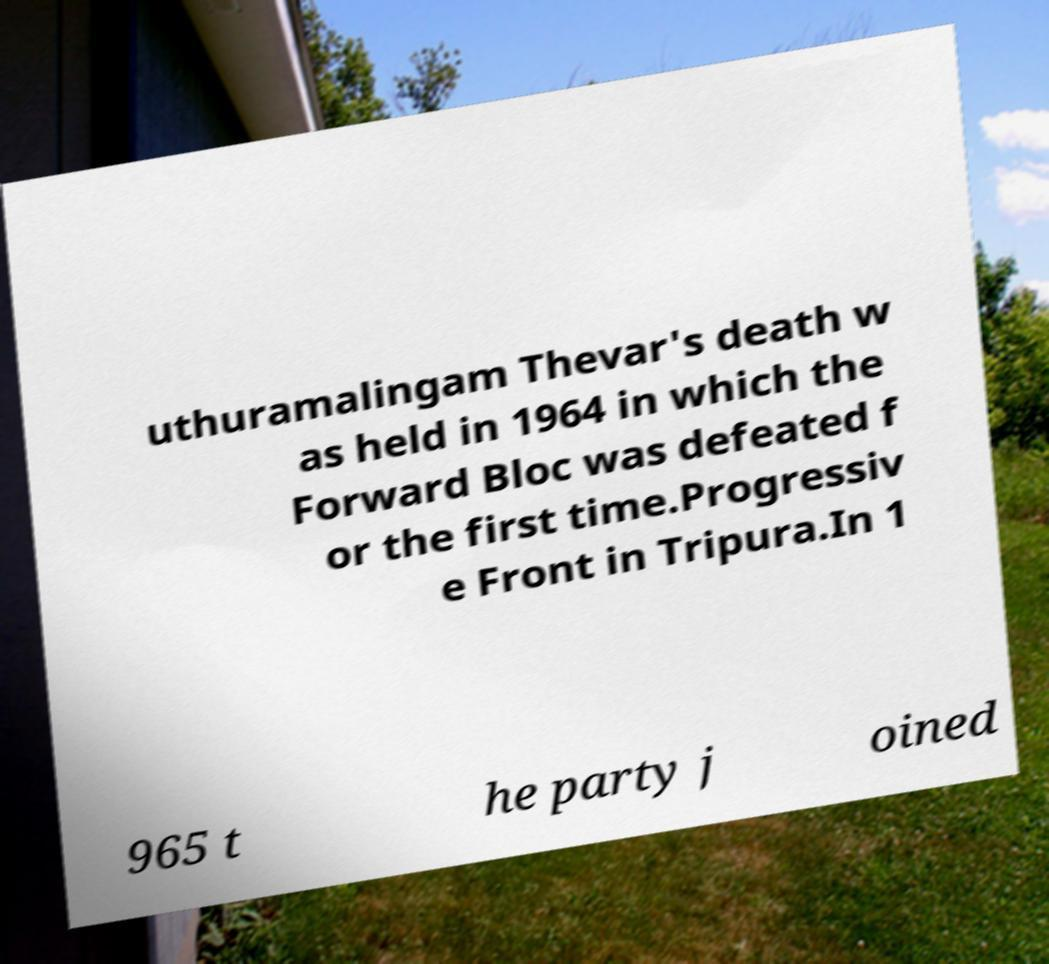I need the written content from this picture converted into text. Can you do that? uthuramalingam Thevar's death w as held in 1964 in which the Forward Bloc was defeated f or the first time.Progressiv e Front in Tripura.In 1 965 t he party j oined 